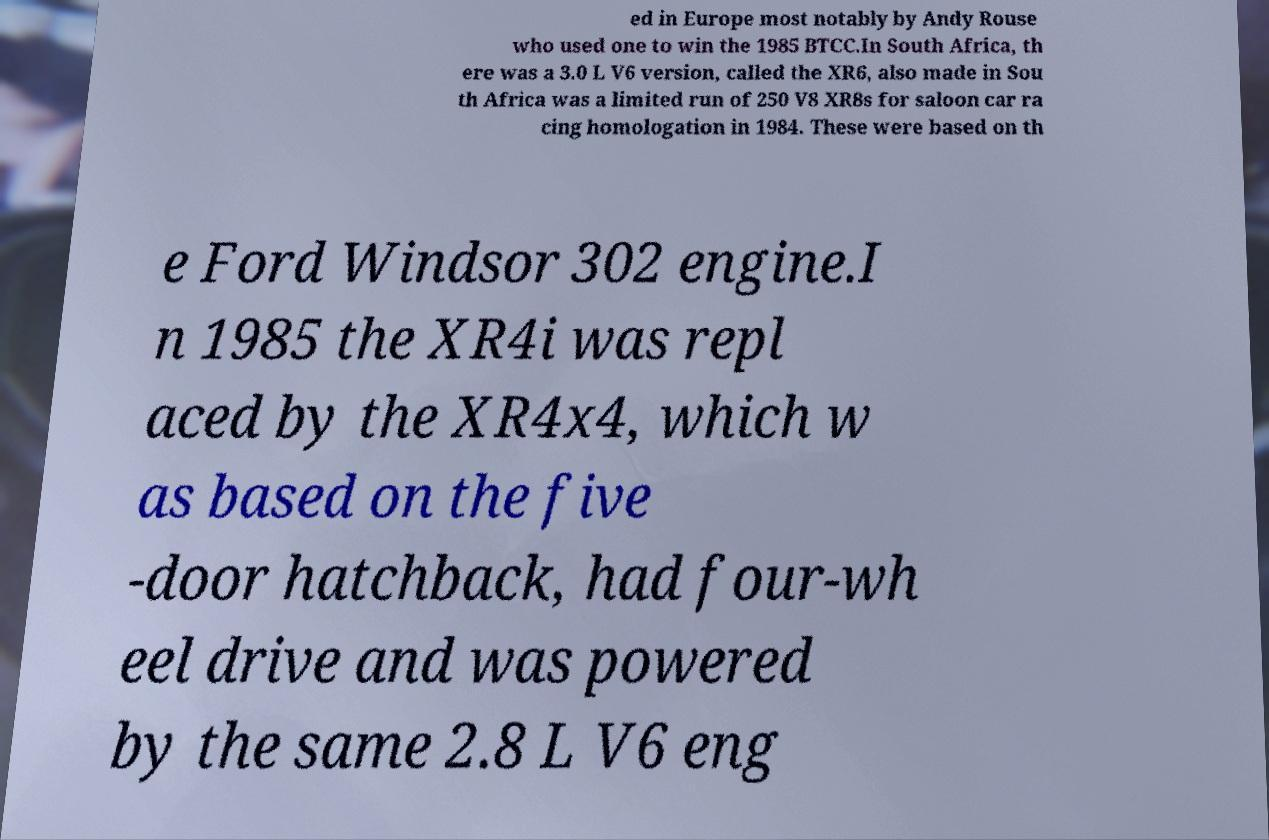Could you assist in decoding the text presented in this image and type it out clearly? ed in Europe most notably by Andy Rouse who used one to win the 1985 BTCC.In South Africa, th ere was a 3.0 L V6 version, called the XR6, also made in Sou th Africa was a limited run of 250 V8 XR8s for saloon car ra cing homologation in 1984. These were based on th e Ford Windsor 302 engine.I n 1985 the XR4i was repl aced by the XR4x4, which w as based on the five -door hatchback, had four-wh eel drive and was powered by the same 2.8 L V6 eng 